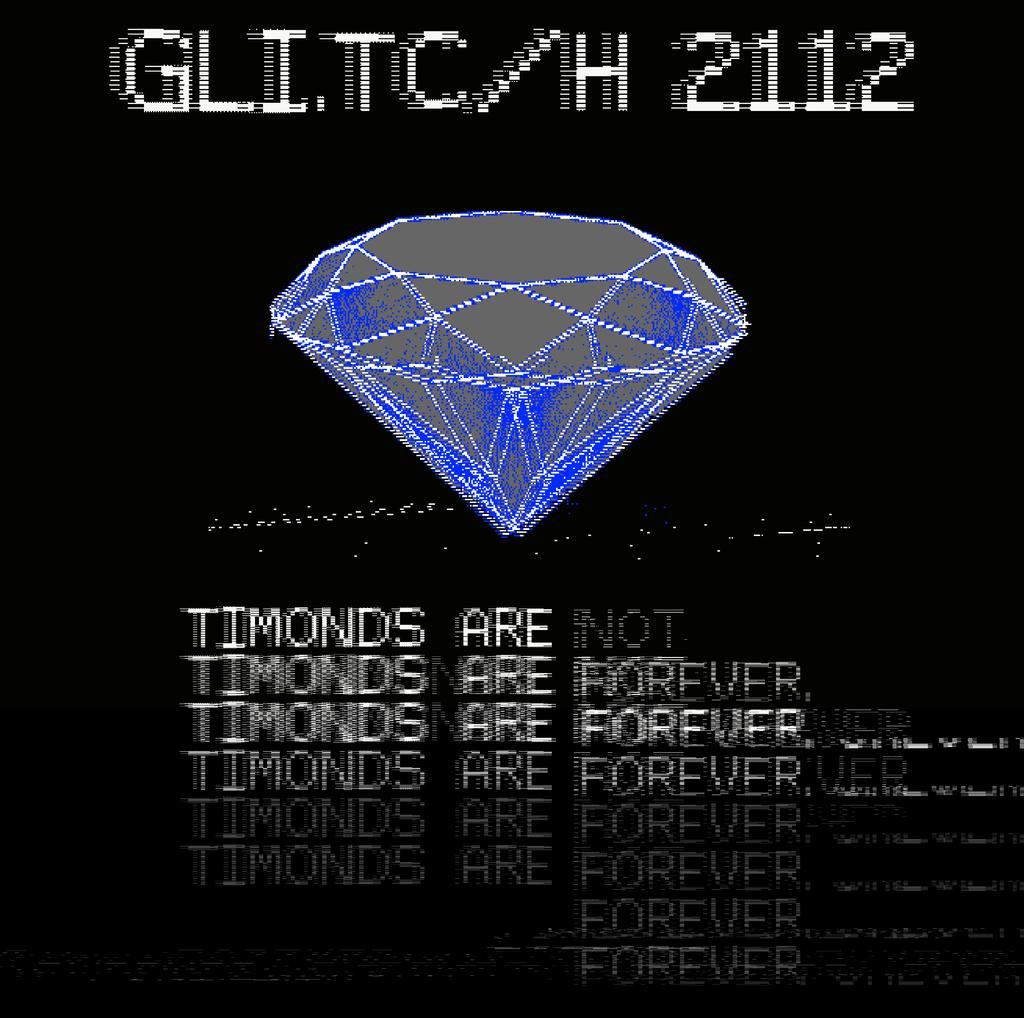<image>
Create a compact narrative representing the image presented. A diamond rests in the center of a black background with the letters glitc/h above it. 